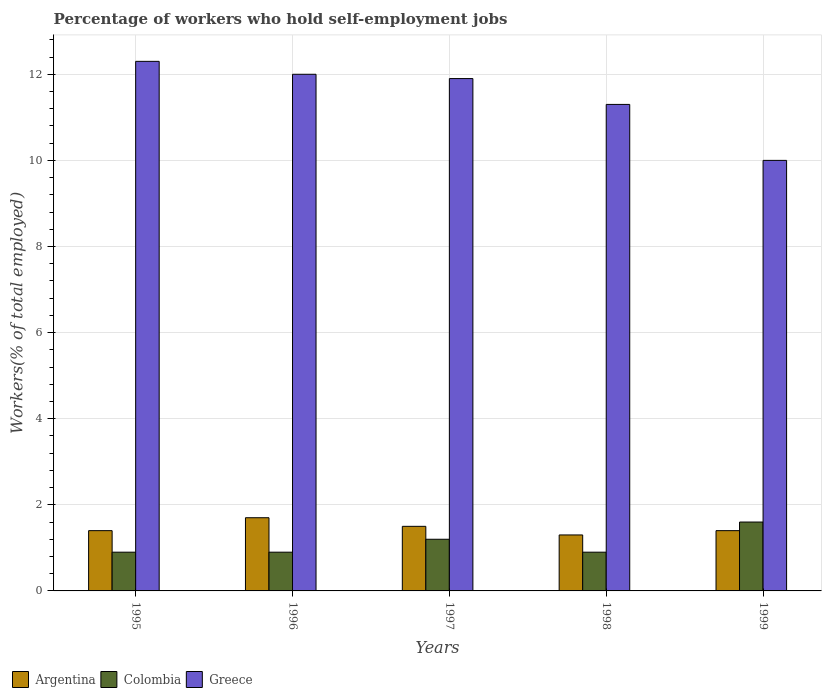How many different coloured bars are there?
Your answer should be compact. 3. How many groups of bars are there?
Keep it short and to the point. 5. Are the number of bars per tick equal to the number of legend labels?
Give a very brief answer. Yes. Are the number of bars on each tick of the X-axis equal?
Keep it short and to the point. Yes. How many bars are there on the 2nd tick from the left?
Provide a succinct answer. 3. How many bars are there on the 5th tick from the right?
Your answer should be very brief. 3. What is the label of the 5th group of bars from the left?
Provide a succinct answer. 1999. In how many cases, is the number of bars for a given year not equal to the number of legend labels?
Keep it short and to the point. 0. What is the percentage of self-employed workers in Colombia in 1998?
Offer a terse response. 0.9. Across all years, what is the maximum percentage of self-employed workers in Argentina?
Give a very brief answer. 1.7. Across all years, what is the minimum percentage of self-employed workers in Argentina?
Provide a short and direct response. 1.3. What is the total percentage of self-employed workers in Colombia in the graph?
Make the answer very short. 5.5. What is the difference between the percentage of self-employed workers in Greece in 1995 and that in 1996?
Your response must be concise. 0.3. What is the difference between the percentage of self-employed workers in Greece in 1996 and the percentage of self-employed workers in Colombia in 1995?
Offer a terse response. 11.1. What is the average percentage of self-employed workers in Argentina per year?
Provide a short and direct response. 1.46. In the year 1999, what is the difference between the percentage of self-employed workers in Colombia and percentage of self-employed workers in Greece?
Make the answer very short. -8.4. What is the ratio of the percentage of self-employed workers in Colombia in 1997 to that in 1998?
Provide a succinct answer. 1.33. Is the percentage of self-employed workers in Argentina in 1997 less than that in 1999?
Offer a very short reply. No. Is the difference between the percentage of self-employed workers in Colombia in 1998 and 1999 greater than the difference between the percentage of self-employed workers in Greece in 1998 and 1999?
Give a very brief answer. No. What is the difference between the highest and the second highest percentage of self-employed workers in Colombia?
Your response must be concise. 0.4. What is the difference between the highest and the lowest percentage of self-employed workers in Greece?
Give a very brief answer. 2.3. In how many years, is the percentage of self-employed workers in Greece greater than the average percentage of self-employed workers in Greece taken over all years?
Your answer should be very brief. 3. Is the sum of the percentage of self-employed workers in Greece in 1995 and 1996 greater than the maximum percentage of self-employed workers in Argentina across all years?
Give a very brief answer. Yes. What does the 3rd bar from the left in 1999 represents?
Offer a very short reply. Greece. What does the 2nd bar from the right in 1997 represents?
Your answer should be very brief. Colombia. What is the difference between two consecutive major ticks on the Y-axis?
Provide a short and direct response. 2. Are the values on the major ticks of Y-axis written in scientific E-notation?
Your answer should be very brief. No. Where does the legend appear in the graph?
Offer a terse response. Bottom left. How many legend labels are there?
Provide a succinct answer. 3. What is the title of the graph?
Give a very brief answer. Percentage of workers who hold self-employment jobs. Does "Japan" appear as one of the legend labels in the graph?
Provide a succinct answer. No. What is the label or title of the Y-axis?
Give a very brief answer. Workers(% of total employed). What is the Workers(% of total employed) of Argentina in 1995?
Your answer should be very brief. 1.4. What is the Workers(% of total employed) of Colombia in 1995?
Offer a very short reply. 0.9. What is the Workers(% of total employed) of Greece in 1995?
Offer a terse response. 12.3. What is the Workers(% of total employed) in Argentina in 1996?
Provide a short and direct response. 1.7. What is the Workers(% of total employed) of Colombia in 1996?
Ensure brevity in your answer.  0.9. What is the Workers(% of total employed) in Argentina in 1997?
Provide a succinct answer. 1.5. What is the Workers(% of total employed) of Colombia in 1997?
Offer a terse response. 1.2. What is the Workers(% of total employed) in Greece in 1997?
Provide a short and direct response. 11.9. What is the Workers(% of total employed) in Argentina in 1998?
Your answer should be very brief. 1.3. What is the Workers(% of total employed) in Colombia in 1998?
Your response must be concise. 0.9. What is the Workers(% of total employed) in Greece in 1998?
Your answer should be very brief. 11.3. What is the Workers(% of total employed) of Argentina in 1999?
Provide a short and direct response. 1.4. What is the Workers(% of total employed) of Colombia in 1999?
Make the answer very short. 1.6. What is the Workers(% of total employed) in Greece in 1999?
Offer a very short reply. 10. Across all years, what is the maximum Workers(% of total employed) of Argentina?
Provide a short and direct response. 1.7. Across all years, what is the maximum Workers(% of total employed) of Colombia?
Offer a terse response. 1.6. Across all years, what is the maximum Workers(% of total employed) of Greece?
Give a very brief answer. 12.3. Across all years, what is the minimum Workers(% of total employed) of Argentina?
Offer a very short reply. 1.3. Across all years, what is the minimum Workers(% of total employed) in Colombia?
Keep it short and to the point. 0.9. What is the total Workers(% of total employed) of Greece in the graph?
Provide a short and direct response. 57.5. What is the difference between the Workers(% of total employed) of Argentina in 1995 and that in 1996?
Offer a very short reply. -0.3. What is the difference between the Workers(% of total employed) of Colombia in 1995 and that in 1996?
Your response must be concise. 0. What is the difference between the Workers(% of total employed) of Greece in 1995 and that in 1996?
Ensure brevity in your answer.  0.3. What is the difference between the Workers(% of total employed) of Argentina in 1995 and that in 1997?
Give a very brief answer. -0.1. What is the difference between the Workers(% of total employed) in Colombia in 1995 and that in 1997?
Offer a very short reply. -0.3. What is the difference between the Workers(% of total employed) in Argentina in 1995 and that in 1998?
Your response must be concise. 0.1. What is the difference between the Workers(% of total employed) of Colombia in 1995 and that in 1998?
Offer a terse response. 0. What is the difference between the Workers(% of total employed) in Argentina in 1995 and that in 1999?
Provide a short and direct response. 0. What is the difference between the Workers(% of total employed) of Greece in 1995 and that in 1999?
Offer a very short reply. 2.3. What is the difference between the Workers(% of total employed) of Greece in 1996 and that in 1997?
Ensure brevity in your answer.  0.1. What is the difference between the Workers(% of total employed) of Argentina in 1996 and that in 1998?
Provide a succinct answer. 0.4. What is the difference between the Workers(% of total employed) in Greece in 1996 and that in 1998?
Provide a short and direct response. 0.7. What is the difference between the Workers(% of total employed) in Argentina in 1996 and that in 1999?
Your answer should be compact. 0.3. What is the difference between the Workers(% of total employed) of Colombia in 1996 and that in 1999?
Your response must be concise. -0.7. What is the difference between the Workers(% of total employed) of Greece in 1996 and that in 1999?
Provide a succinct answer. 2. What is the difference between the Workers(% of total employed) of Argentina in 1997 and that in 1998?
Offer a terse response. 0.2. What is the difference between the Workers(% of total employed) of Argentina in 1998 and that in 1999?
Offer a very short reply. -0.1. What is the difference between the Workers(% of total employed) in Colombia in 1998 and that in 1999?
Provide a short and direct response. -0.7. What is the difference between the Workers(% of total employed) of Greece in 1998 and that in 1999?
Make the answer very short. 1.3. What is the difference between the Workers(% of total employed) in Argentina in 1995 and the Workers(% of total employed) in Greece in 1997?
Offer a very short reply. -10.5. What is the difference between the Workers(% of total employed) of Argentina in 1995 and the Workers(% of total employed) of Greece in 1998?
Provide a succinct answer. -9.9. What is the difference between the Workers(% of total employed) of Colombia in 1995 and the Workers(% of total employed) of Greece in 1998?
Make the answer very short. -10.4. What is the difference between the Workers(% of total employed) of Argentina in 1995 and the Workers(% of total employed) of Greece in 1999?
Your answer should be compact. -8.6. What is the difference between the Workers(% of total employed) in Argentina in 1996 and the Workers(% of total employed) in Colombia in 1998?
Give a very brief answer. 0.8. What is the difference between the Workers(% of total employed) of Argentina in 1996 and the Workers(% of total employed) of Greece in 1998?
Ensure brevity in your answer.  -9.6. What is the difference between the Workers(% of total employed) in Argentina in 1996 and the Workers(% of total employed) in Colombia in 1999?
Ensure brevity in your answer.  0.1. What is the difference between the Workers(% of total employed) in Colombia in 1996 and the Workers(% of total employed) in Greece in 1999?
Provide a short and direct response. -9.1. What is the difference between the Workers(% of total employed) in Argentina in 1997 and the Workers(% of total employed) in Colombia in 1998?
Your answer should be very brief. 0.6. What is the difference between the Workers(% of total employed) in Argentina in 1997 and the Workers(% of total employed) in Greece in 1999?
Ensure brevity in your answer.  -8.5. What is the difference between the Workers(% of total employed) of Argentina in 1998 and the Workers(% of total employed) of Colombia in 1999?
Provide a succinct answer. -0.3. What is the difference between the Workers(% of total employed) in Argentina in 1998 and the Workers(% of total employed) in Greece in 1999?
Make the answer very short. -8.7. What is the average Workers(% of total employed) in Argentina per year?
Your answer should be compact. 1.46. What is the average Workers(% of total employed) of Colombia per year?
Offer a terse response. 1.1. What is the average Workers(% of total employed) of Greece per year?
Ensure brevity in your answer.  11.5. In the year 1995, what is the difference between the Workers(% of total employed) of Argentina and Workers(% of total employed) of Colombia?
Make the answer very short. 0.5. In the year 1997, what is the difference between the Workers(% of total employed) in Argentina and Workers(% of total employed) in Colombia?
Offer a very short reply. 0.3. In the year 1997, what is the difference between the Workers(% of total employed) in Colombia and Workers(% of total employed) in Greece?
Offer a terse response. -10.7. In the year 1998, what is the difference between the Workers(% of total employed) of Argentina and Workers(% of total employed) of Colombia?
Your response must be concise. 0.4. In the year 1998, what is the difference between the Workers(% of total employed) in Argentina and Workers(% of total employed) in Greece?
Make the answer very short. -10. In the year 1998, what is the difference between the Workers(% of total employed) of Colombia and Workers(% of total employed) of Greece?
Give a very brief answer. -10.4. In the year 1999, what is the difference between the Workers(% of total employed) in Argentina and Workers(% of total employed) in Greece?
Your answer should be very brief. -8.6. In the year 1999, what is the difference between the Workers(% of total employed) in Colombia and Workers(% of total employed) in Greece?
Offer a very short reply. -8.4. What is the ratio of the Workers(% of total employed) in Argentina in 1995 to that in 1996?
Your response must be concise. 0.82. What is the ratio of the Workers(% of total employed) in Greece in 1995 to that in 1997?
Provide a succinct answer. 1.03. What is the ratio of the Workers(% of total employed) of Argentina in 1995 to that in 1998?
Your answer should be very brief. 1.08. What is the ratio of the Workers(% of total employed) in Colombia in 1995 to that in 1998?
Your answer should be compact. 1. What is the ratio of the Workers(% of total employed) in Greece in 1995 to that in 1998?
Offer a very short reply. 1.09. What is the ratio of the Workers(% of total employed) of Colombia in 1995 to that in 1999?
Offer a very short reply. 0.56. What is the ratio of the Workers(% of total employed) of Greece in 1995 to that in 1999?
Keep it short and to the point. 1.23. What is the ratio of the Workers(% of total employed) in Argentina in 1996 to that in 1997?
Provide a succinct answer. 1.13. What is the ratio of the Workers(% of total employed) in Greece in 1996 to that in 1997?
Your answer should be very brief. 1.01. What is the ratio of the Workers(% of total employed) of Argentina in 1996 to that in 1998?
Your answer should be very brief. 1.31. What is the ratio of the Workers(% of total employed) of Colombia in 1996 to that in 1998?
Keep it short and to the point. 1. What is the ratio of the Workers(% of total employed) in Greece in 1996 to that in 1998?
Make the answer very short. 1.06. What is the ratio of the Workers(% of total employed) of Argentina in 1996 to that in 1999?
Keep it short and to the point. 1.21. What is the ratio of the Workers(% of total employed) of Colombia in 1996 to that in 1999?
Offer a very short reply. 0.56. What is the ratio of the Workers(% of total employed) in Greece in 1996 to that in 1999?
Your response must be concise. 1.2. What is the ratio of the Workers(% of total employed) of Argentina in 1997 to that in 1998?
Your response must be concise. 1.15. What is the ratio of the Workers(% of total employed) in Colombia in 1997 to that in 1998?
Offer a very short reply. 1.33. What is the ratio of the Workers(% of total employed) of Greece in 1997 to that in 1998?
Your answer should be very brief. 1.05. What is the ratio of the Workers(% of total employed) of Argentina in 1997 to that in 1999?
Give a very brief answer. 1.07. What is the ratio of the Workers(% of total employed) in Greece in 1997 to that in 1999?
Your response must be concise. 1.19. What is the ratio of the Workers(% of total employed) in Argentina in 1998 to that in 1999?
Give a very brief answer. 0.93. What is the ratio of the Workers(% of total employed) in Colombia in 1998 to that in 1999?
Give a very brief answer. 0.56. What is the ratio of the Workers(% of total employed) of Greece in 1998 to that in 1999?
Your answer should be compact. 1.13. What is the difference between the highest and the second highest Workers(% of total employed) of Argentina?
Your answer should be very brief. 0.2. What is the difference between the highest and the lowest Workers(% of total employed) of Colombia?
Your answer should be very brief. 0.7. What is the difference between the highest and the lowest Workers(% of total employed) of Greece?
Offer a very short reply. 2.3. 